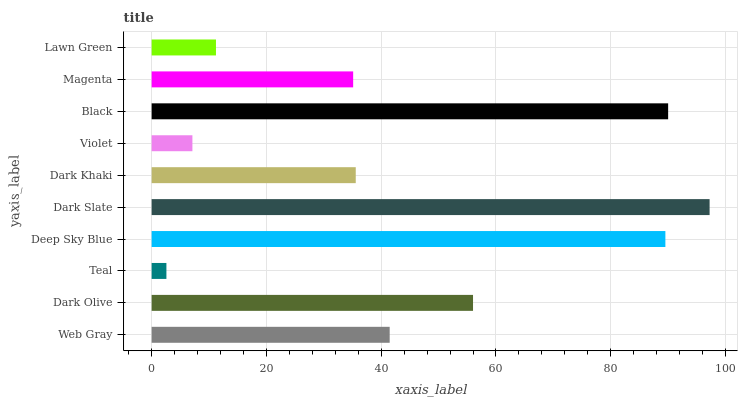Is Teal the minimum?
Answer yes or no. Yes. Is Dark Slate the maximum?
Answer yes or no. Yes. Is Dark Olive the minimum?
Answer yes or no. No. Is Dark Olive the maximum?
Answer yes or no. No. Is Dark Olive greater than Web Gray?
Answer yes or no. Yes. Is Web Gray less than Dark Olive?
Answer yes or no. Yes. Is Web Gray greater than Dark Olive?
Answer yes or no. No. Is Dark Olive less than Web Gray?
Answer yes or no. No. Is Web Gray the high median?
Answer yes or no. Yes. Is Dark Khaki the low median?
Answer yes or no. Yes. Is Dark Slate the high median?
Answer yes or no. No. Is Violet the low median?
Answer yes or no. No. 